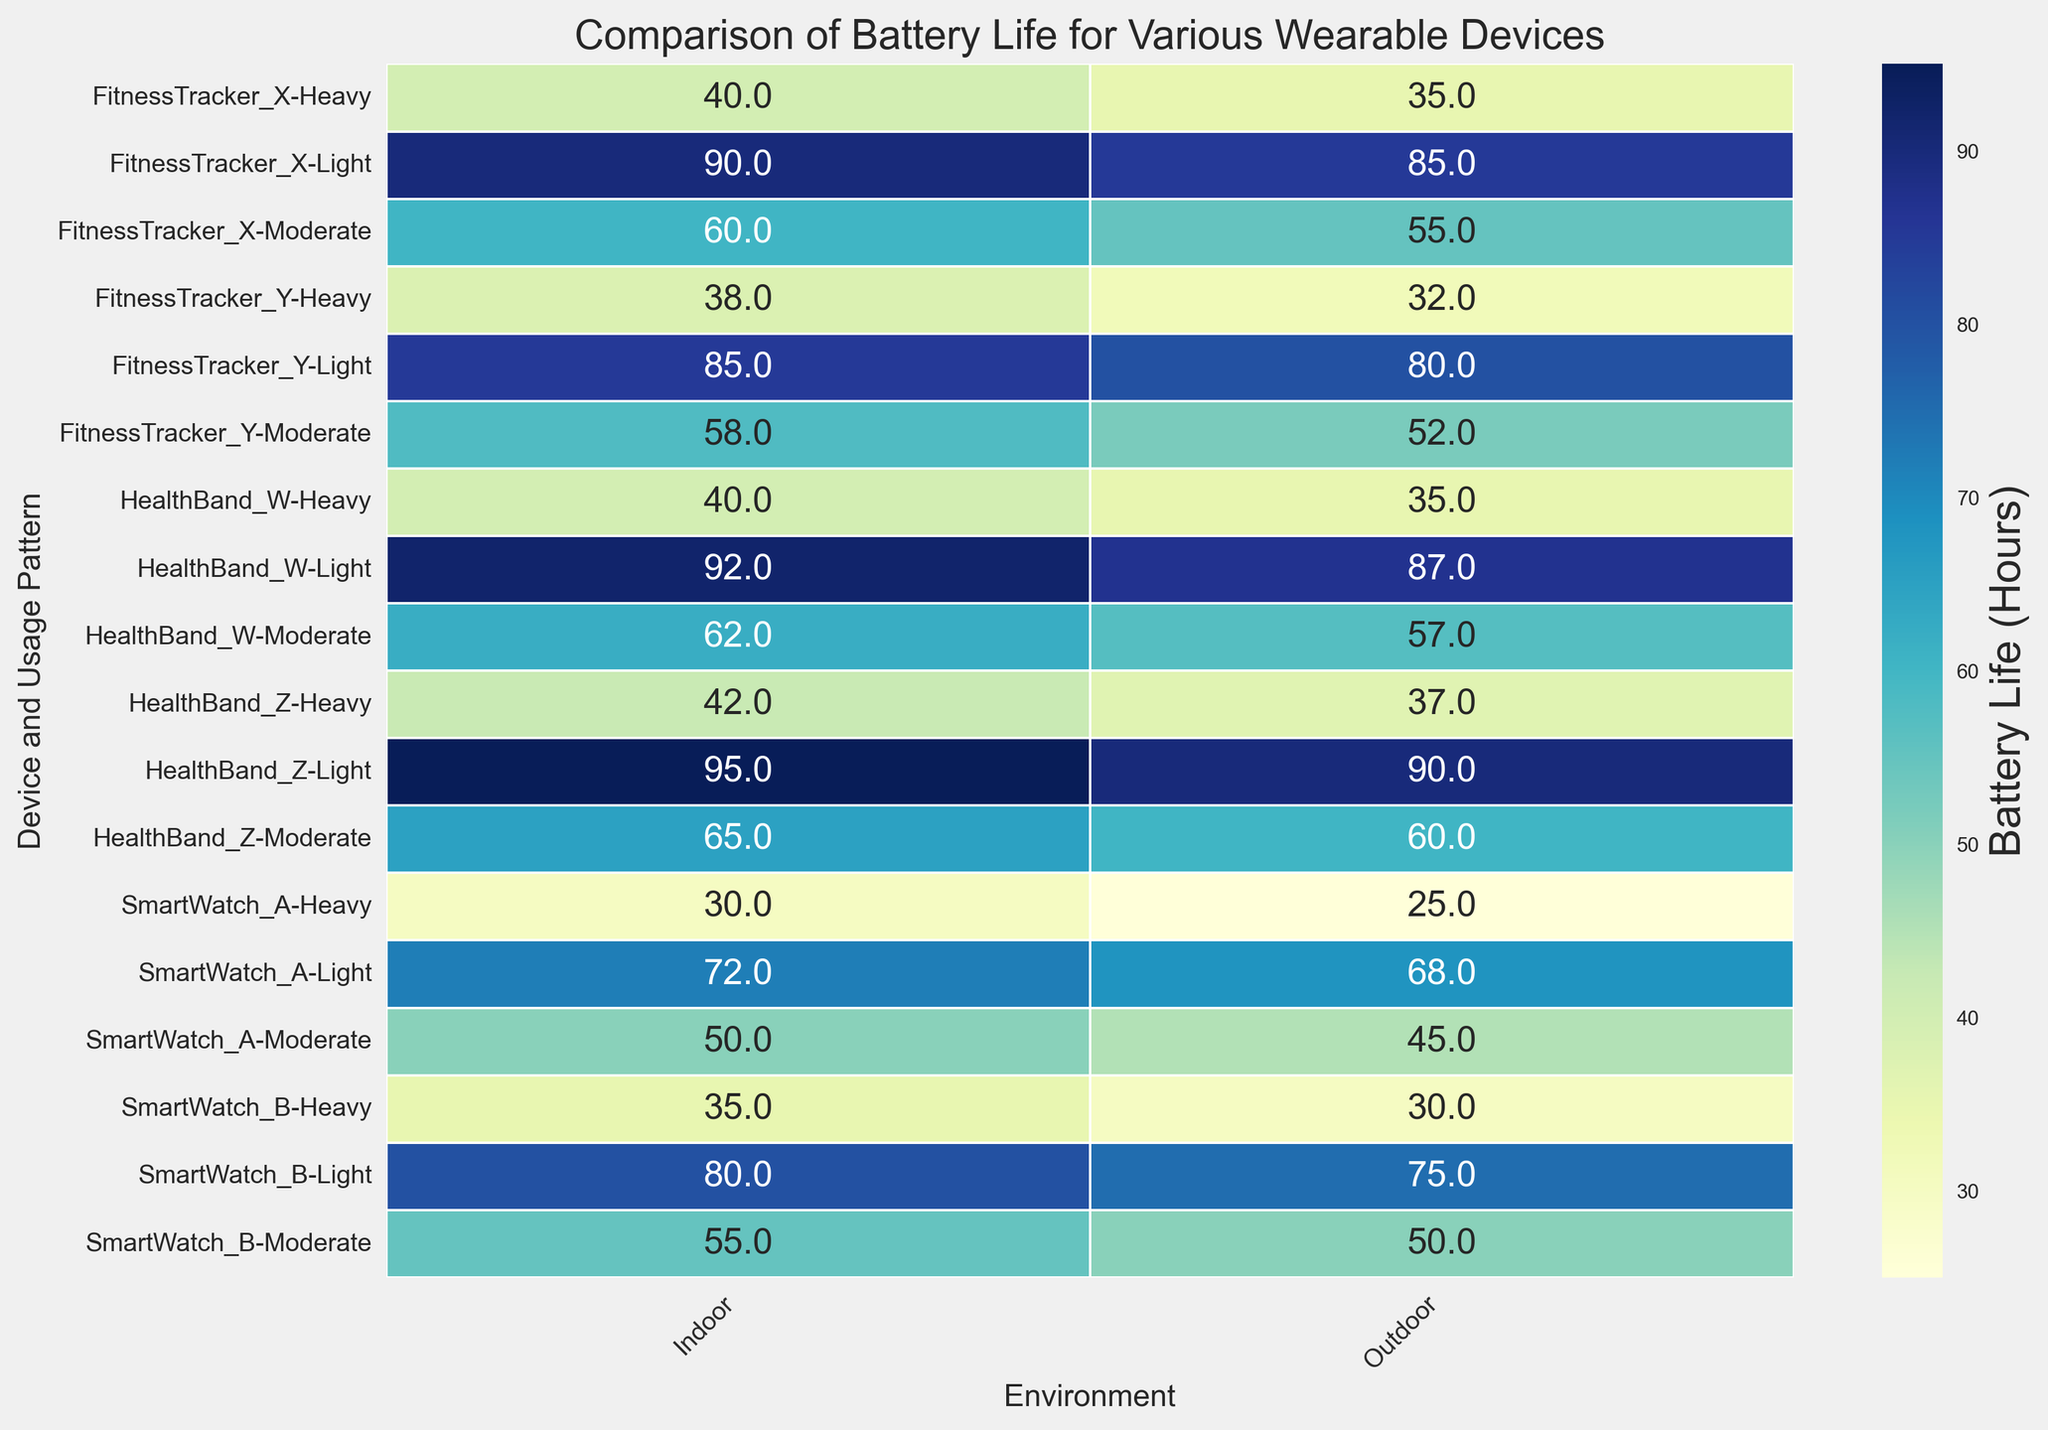What's the device with the longest battery life in an outdoor environment? Check the heatmap for the highest value in the columns under 'Outdoor' environments and identify the corresponding device. HealthBand_Z has the highest battery life of 90 hours outdoors.
Answer: HealthBand_Z How does the battery life of SmartWatch_A compare in light usage between indoor and outdoor environments? Look at the battery life for SmartWatch_A under 'Light' usage in both 'Indoor' and 'Outdoor' columns. The indoor battery life is 72 hours, and the outdoor is 68 hours, showing that the indoor environment provides a longer battery life.
Answer: Indoor is 4 hours more than outdoor Which device shows the highest decrement in battery life when moving from a light to a heavy usage pattern indoors? Find the difference in battery life between 'Light' and 'Heavy' usage within the 'Indoor' rows for each device. The device with the highest decrement is HealthBand_Z with a difference of 95 - 42 = 53 hours.
Answer: HealthBand_Z Is there a pattern that shows better battery performance for 'Light' usage across all devices? Observe the 'Light' usage rows across all devices in both 'Indoor' and 'Outdoor' columns and compare them with the 'Moderate' and 'Heavy' usage rows. Generally, 'Light' usage consistently has higher battery life values.
Answer: Yes, better performance in 'Light' usage Which device experiences the steepest decline in battery life when moving from an indoor to an outdoor environment under moderate usage? Compare the moderate usage battery life values between 'Indoor' and 'Outdoor' for each device, calculating the differences. SmartWatch_A shows a drop from 50 to 45 hours, indicating the steepest decline by 5 hours.
Answer: SmartWatch_A What's the combined battery life of FitnessTracker_X under heavy usage in both indoor and outdoor environments? Sum the battery life values for FitnessTracker_X under 'Heavy' usage in both 'Indoor' and 'Outdoor' columns. The combined battery life is 40 + 35 = 75 hours.
Answer: 75 hours Which color represents the longest battery life by visual inspection, and what does it indicate about the device and environment? The darkest shade of blue represents the longest battery life. By observing the heatmap, HealthBand_Z in an indoor environment under light usage has the darkest blue indicating a battery life of 95 hours.
Answer: Darkest blue, HealthBand_Z indoor under light usage Are there any devices that have the same battery life in both indoor and outdoor environments for a specific usage pattern? Look through the heatmap to find any rows where battery life values under 'Indoor' and 'Outdoor' columns are identical. No such device has the same battery life in both environments across any usage pattern.
Answer: No What's the average battery life of HealthBand_W in an outdoor environment across all usage patterns? Sum the battery life values for HealthBand_W in the 'Outdoor' column and divide by the number of usage patterns. (87 + 57 + 35) / 3 = 179 / 3 = 59.67 hours.
Answer: 59.67 hours What's the range of battery life values for all devices under moderate usage in an outdoor environment? Identify the highest and lowest battery life values under 'Moderate' usage in the 'Outdoor' column. The highest is HealthBand_Z with 60 hours, and the lowest is SmartWatch_A with 45 hours. The range is 60 - 45 = 15 hours.
Answer: 15 hours 